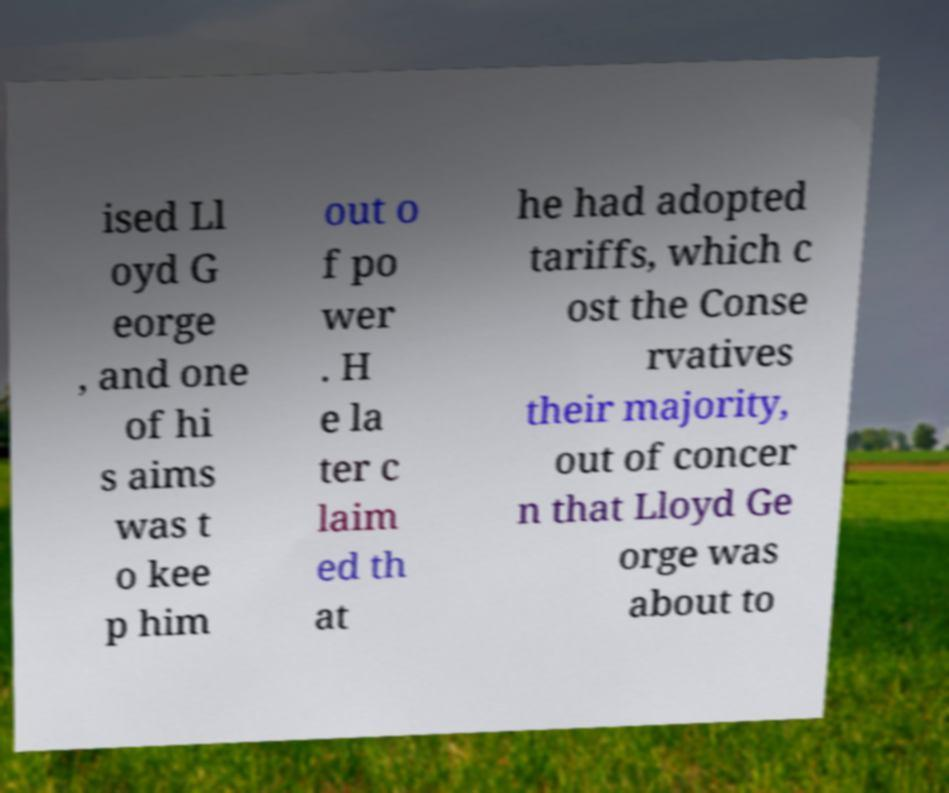I need the written content from this picture converted into text. Can you do that? ised Ll oyd G eorge , and one of hi s aims was t o kee p him out o f po wer . H e la ter c laim ed th at he had adopted tariffs, which c ost the Conse rvatives their majority, out of concer n that Lloyd Ge orge was about to 